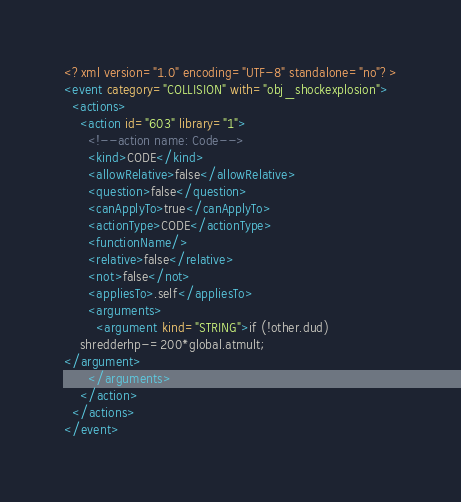Convert code to text. <code><loc_0><loc_0><loc_500><loc_500><_XML_><?xml version="1.0" encoding="UTF-8" standalone="no"?>
<event category="COLLISION" with="obj_shockexplosion">
  <actions>
    <action id="603" library="1">
      <!--action name: Code-->
      <kind>CODE</kind>
      <allowRelative>false</allowRelative>
      <question>false</question>
      <canApplyTo>true</canApplyTo>
      <actionType>CODE</actionType>
      <functionName/>
      <relative>false</relative>
      <not>false</not>
      <appliesTo>.self</appliesTo>
      <arguments>
        <argument kind="STRING">if (!other.dud)
    shredderhp-=200*global.atmult;
</argument>
      </arguments>
    </action>
  </actions>
</event>
</code> 